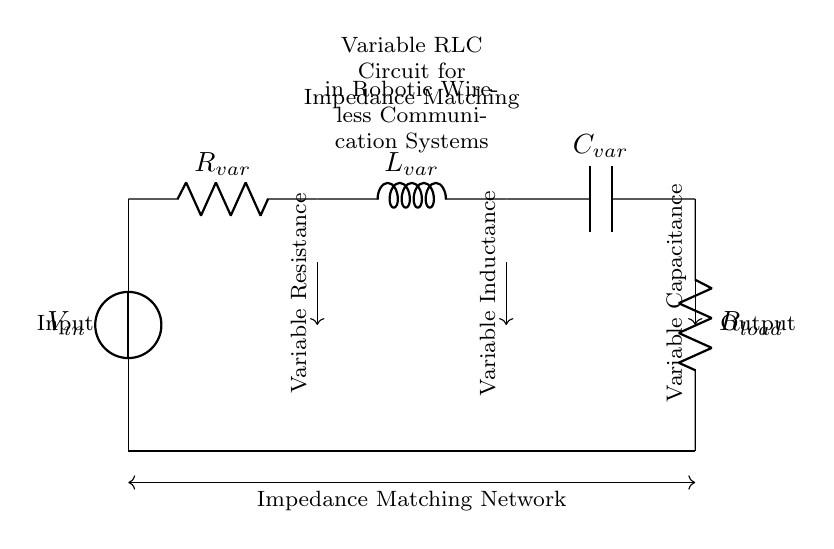What type of circuit is shown? The circuit diagram presents a variable RLC circuit, which consists of variable resistance, inductance, and capacitance, indicating it is designed for impedance matching.
Answer: variable RLC circuit What is the role of R var in this circuit? R var serves as a variable resistor, allowing for adjustments in resistance to optimize the impedance matching between the input and output.
Answer: variable resistor How many components are there in this circuit? The circuit consists of five main components: one voltage source, one variable resistor, one variable inductor, one variable capacitor, and one load resistor.
Answer: five What happens to the circuit when L var is increased? Increasing L var raises the inductive reactance, which can affect the overall impedance and potentially optimize signal transfer in the wireless communication system.
Answer: raises inductive reactance What is the purpose of this circuit in robotic systems? The purpose of this circuit is to match impedance, thereby maximizing power transfer and minimizing signal reflection in robotic wireless communication systems.
Answer: impedance matching Which component would you adjust to change capacitance? To change capacitance, C var should be adjusted, as it is specifically labeled as the variable capacitor in the circuit.
Answer: variable capacitor What is the expected outcome of proper impedance matching? Proper impedance matching results in improved signal transmission and reduced loss, leading to better communication performance in robotic systems.
Answer: improved signal transmission 